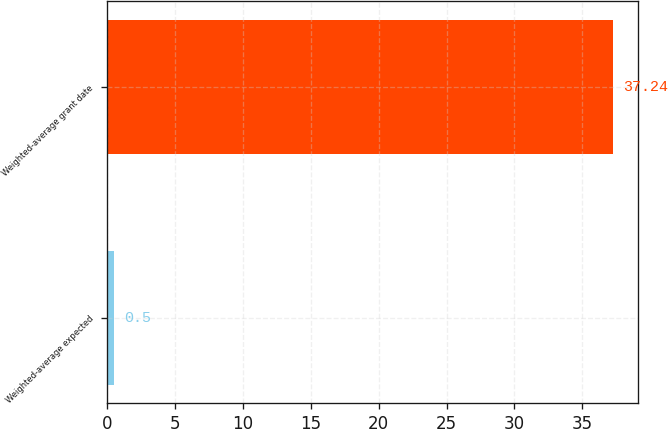Convert chart. <chart><loc_0><loc_0><loc_500><loc_500><bar_chart><fcel>Weighted-average expected<fcel>Weighted-average grant date<nl><fcel>0.5<fcel>37.24<nl></chart> 